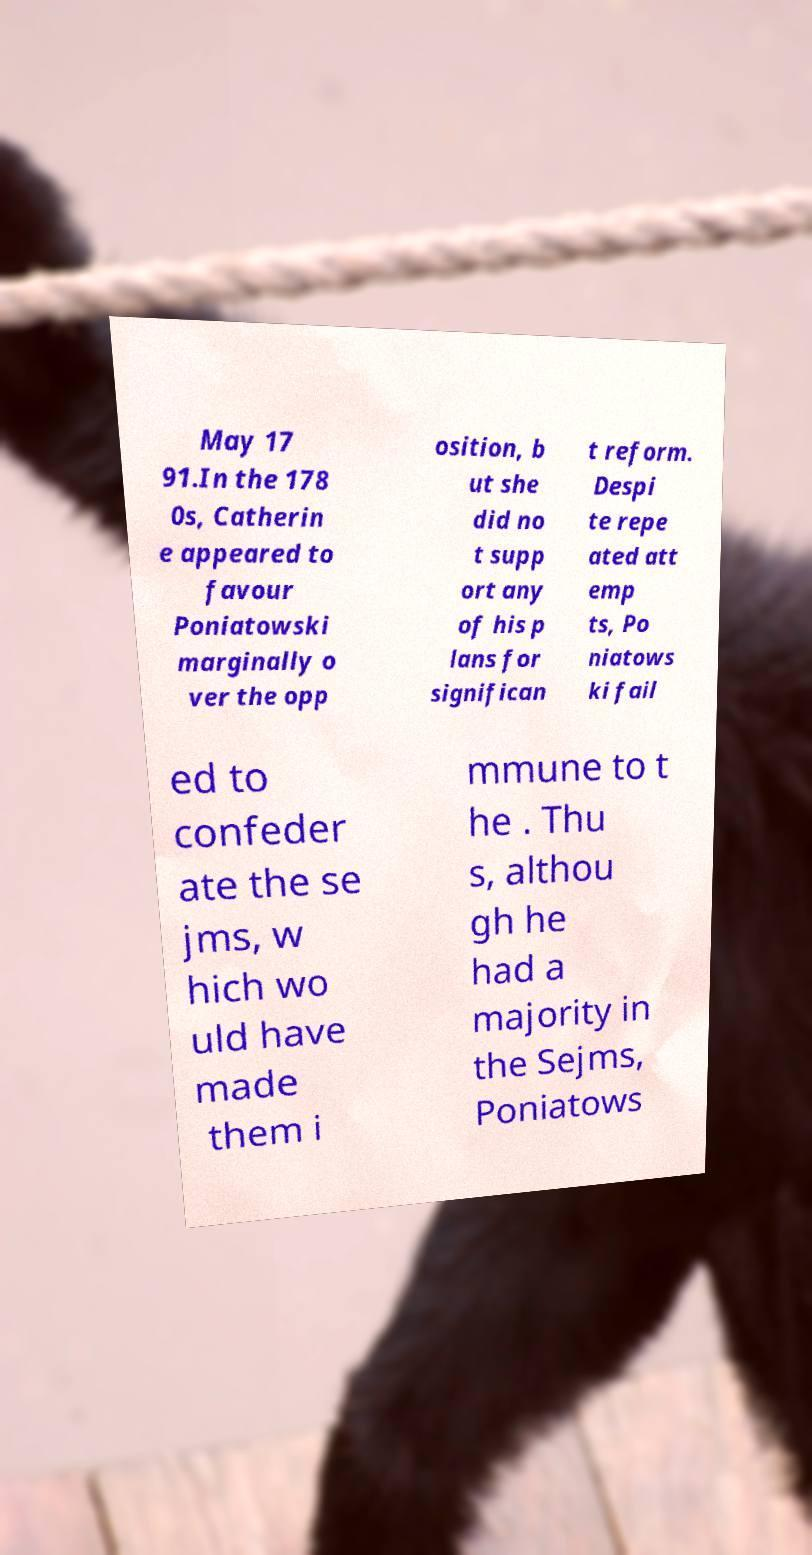Could you extract and type out the text from this image? May 17 91.In the 178 0s, Catherin e appeared to favour Poniatowski marginally o ver the opp osition, b ut she did no t supp ort any of his p lans for significan t reform. Despi te repe ated att emp ts, Po niatows ki fail ed to confeder ate the se jms, w hich wo uld have made them i mmune to t he . Thu s, althou gh he had a majority in the Sejms, Poniatows 